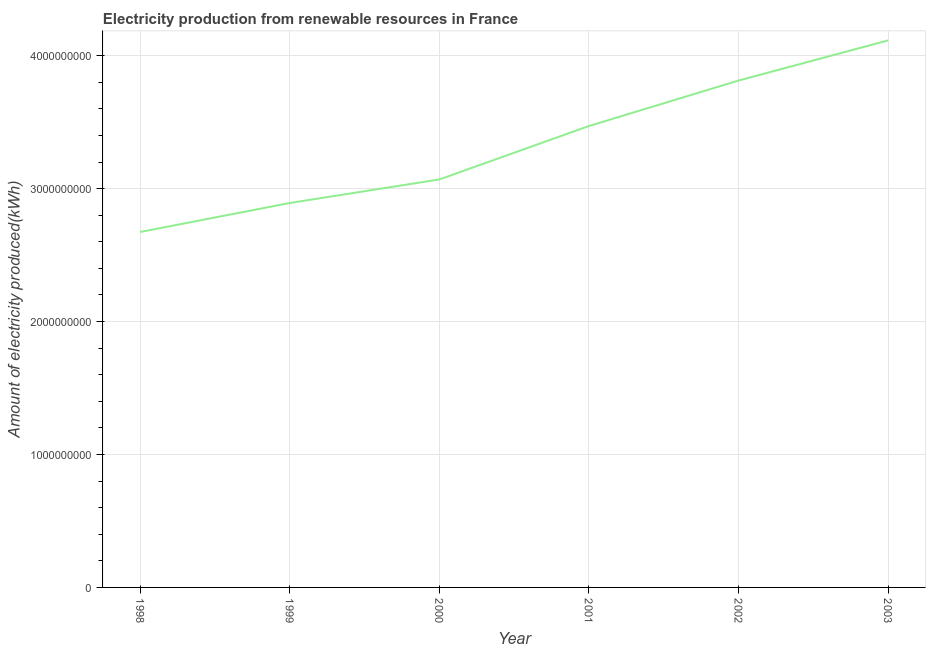What is the amount of electricity produced in 1998?
Your answer should be compact. 2.67e+09. Across all years, what is the maximum amount of electricity produced?
Offer a very short reply. 4.12e+09. Across all years, what is the minimum amount of electricity produced?
Provide a short and direct response. 2.67e+09. In which year was the amount of electricity produced maximum?
Your answer should be compact. 2003. What is the sum of the amount of electricity produced?
Make the answer very short. 2.00e+1. What is the difference between the amount of electricity produced in 1999 and 2003?
Your answer should be compact. -1.22e+09. What is the average amount of electricity produced per year?
Give a very brief answer. 3.34e+09. What is the median amount of electricity produced?
Ensure brevity in your answer.  3.27e+09. What is the ratio of the amount of electricity produced in 1998 to that in 2003?
Make the answer very short. 0.65. Is the amount of electricity produced in 1999 less than that in 2000?
Make the answer very short. Yes. What is the difference between the highest and the second highest amount of electricity produced?
Give a very brief answer. 3.02e+08. Is the sum of the amount of electricity produced in 2000 and 2003 greater than the maximum amount of electricity produced across all years?
Make the answer very short. Yes. What is the difference between the highest and the lowest amount of electricity produced?
Ensure brevity in your answer.  1.44e+09. In how many years, is the amount of electricity produced greater than the average amount of electricity produced taken over all years?
Your answer should be very brief. 3. How many lines are there?
Your response must be concise. 1. What is the difference between two consecutive major ticks on the Y-axis?
Your answer should be compact. 1.00e+09. Does the graph contain any zero values?
Offer a very short reply. No. What is the title of the graph?
Make the answer very short. Electricity production from renewable resources in France. What is the label or title of the Y-axis?
Your answer should be compact. Amount of electricity produced(kWh). What is the Amount of electricity produced(kWh) in 1998?
Give a very brief answer. 2.67e+09. What is the Amount of electricity produced(kWh) of 1999?
Offer a very short reply. 2.89e+09. What is the Amount of electricity produced(kWh) in 2000?
Provide a short and direct response. 3.07e+09. What is the Amount of electricity produced(kWh) of 2001?
Ensure brevity in your answer.  3.47e+09. What is the Amount of electricity produced(kWh) of 2002?
Make the answer very short. 3.81e+09. What is the Amount of electricity produced(kWh) of 2003?
Provide a short and direct response. 4.12e+09. What is the difference between the Amount of electricity produced(kWh) in 1998 and 1999?
Your response must be concise. -2.18e+08. What is the difference between the Amount of electricity produced(kWh) in 1998 and 2000?
Your response must be concise. -3.95e+08. What is the difference between the Amount of electricity produced(kWh) in 1998 and 2001?
Give a very brief answer. -7.97e+08. What is the difference between the Amount of electricity produced(kWh) in 1998 and 2002?
Give a very brief answer. -1.14e+09. What is the difference between the Amount of electricity produced(kWh) in 1998 and 2003?
Make the answer very short. -1.44e+09. What is the difference between the Amount of electricity produced(kWh) in 1999 and 2000?
Your response must be concise. -1.77e+08. What is the difference between the Amount of electricity produced(kWh) in 1999 and 2001?
Keep it short and to the point. -5.79e+08. What is the difference between the Amount of electricity produced(kWh) in 1999 and 2002?
Give a very brief answer. -9.21e+08. What is the difference between the Amount of electricity produced(kWh) in 1999 and 2003?
Ensure brevity in your answer.  -1.22e+09. What is the difference between the Amount of electricity produced(kWh) in 2000 and 2001?
Offer a terse response. -4.02e+08. What is the difference between the Amount of electricity produced(kWh) in 2000 and 2002?
Your response must be concise. -7.44e+08. What is the difference between the Amount of electricity produced(kWh) in 2000 and 2003?
Provide a short and direct response. -1.05e+09. What is the difference between the Amount of electricity produced(kWh) in 2001 and 2002?
Offer a very short reply. -3.42e+08. What is the difference between the Amount of electricity produced(kWh) in 2001 and 2003?
Your answer should be very brief. -6.44e+08. What is the difference between the Amount of electricity produced(kWh) in 2002 and 2003?
Ensure brevity in your answer.  -3.02e+08. What is the ratio of the Amount of electricity produced(kWh) in 1998 to that in 1999?
Your answer should be very brief. 0.93. What is the ratio of the Amount of electricity produced(kWh) in 1998 to that in 2000?
Offer a terse response. 0.87. What is the ratio of the Amount of electricity produced(kWh) in 1998 to that in 2001?
Make the answer very short. 0.77. What is the ratio of the Amount of electricity produced(kWh) in 1998 to that in 2002?
Ensure brevity in your answer.  0.7. What is the ratio of the Amount of electricity produced(kWh) in 1998 to that in 2003?
Make the answer very short. 0.65. What is the ratio of the Amount of electricity produced(kWh) in 1999 to that in 2000?
Provide a succinct answer. 0.94. What is the ratio of the Amount of electricity produced(kWh) in 1999 to that in 2001?
Offer a terse response. 0.83. What is the ratio of the Amount of electricity produced(kWh) in 1999 to that in 2002?
Your answer should be compact. 0.76. What is the ratio of the Amount of electricity produced(kWh) in 1999 to that in 2003?
Provide a succinct answer. 0.7. What is the ratio of the Amount of electricity produced(kWh) in 2000 to that in 2001?
Provide a succinct answer. 0.88. What is the ratio of the Amount of electricity produced(kWh) in 2000 to that in 2002?
Keep it short and to the point. 0.81. What is the ratio of the Amount of electricity produced(kWh) in 2000 to that in 2003?
Offer a very short reply. 0.75. What is the ratio of the Amount of electricity produced(kWh) in 2001 to that in 2002?
Your response must be concise. 0.91. What is the ratio of the Amount of electricity produced(kWh) in 2001 to that in 2003?
Keep it short and to the point. 0.84. What is the ratio of the Amount of electricity produced(kWh) in 2002 to that in 2003?
Offer a very short reply. 0.93. 